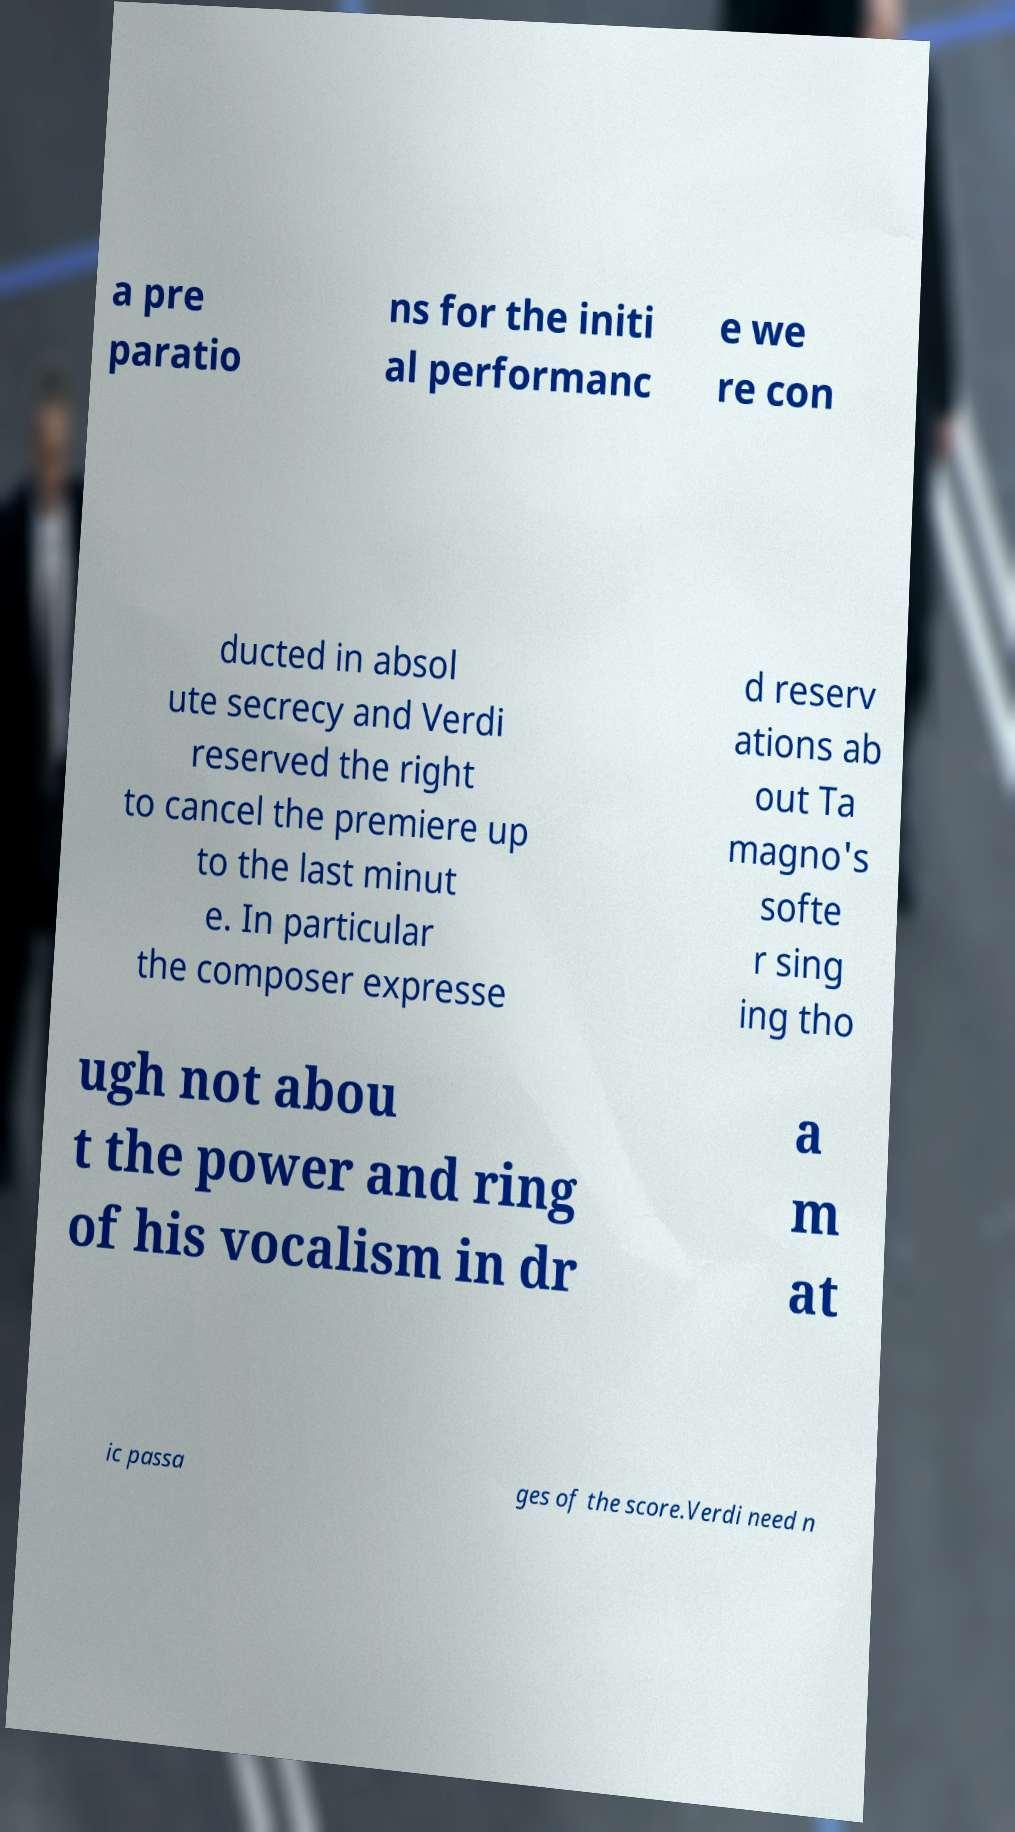What messages or text are displayed in this image? I need them in a readable, typed format. a pre paratio ns for the initi al performanc e we re con ducted in absol ute secrecy and Verdi reserved the right to cancel the premiere up to the last minut e. In particular the composer expresse d reserv ations ab out Ta magno's softe r sing ing tho ugh not abou t the power and ring of his vocalism in dr a m at ic passa ges of the score.Verdi need n 